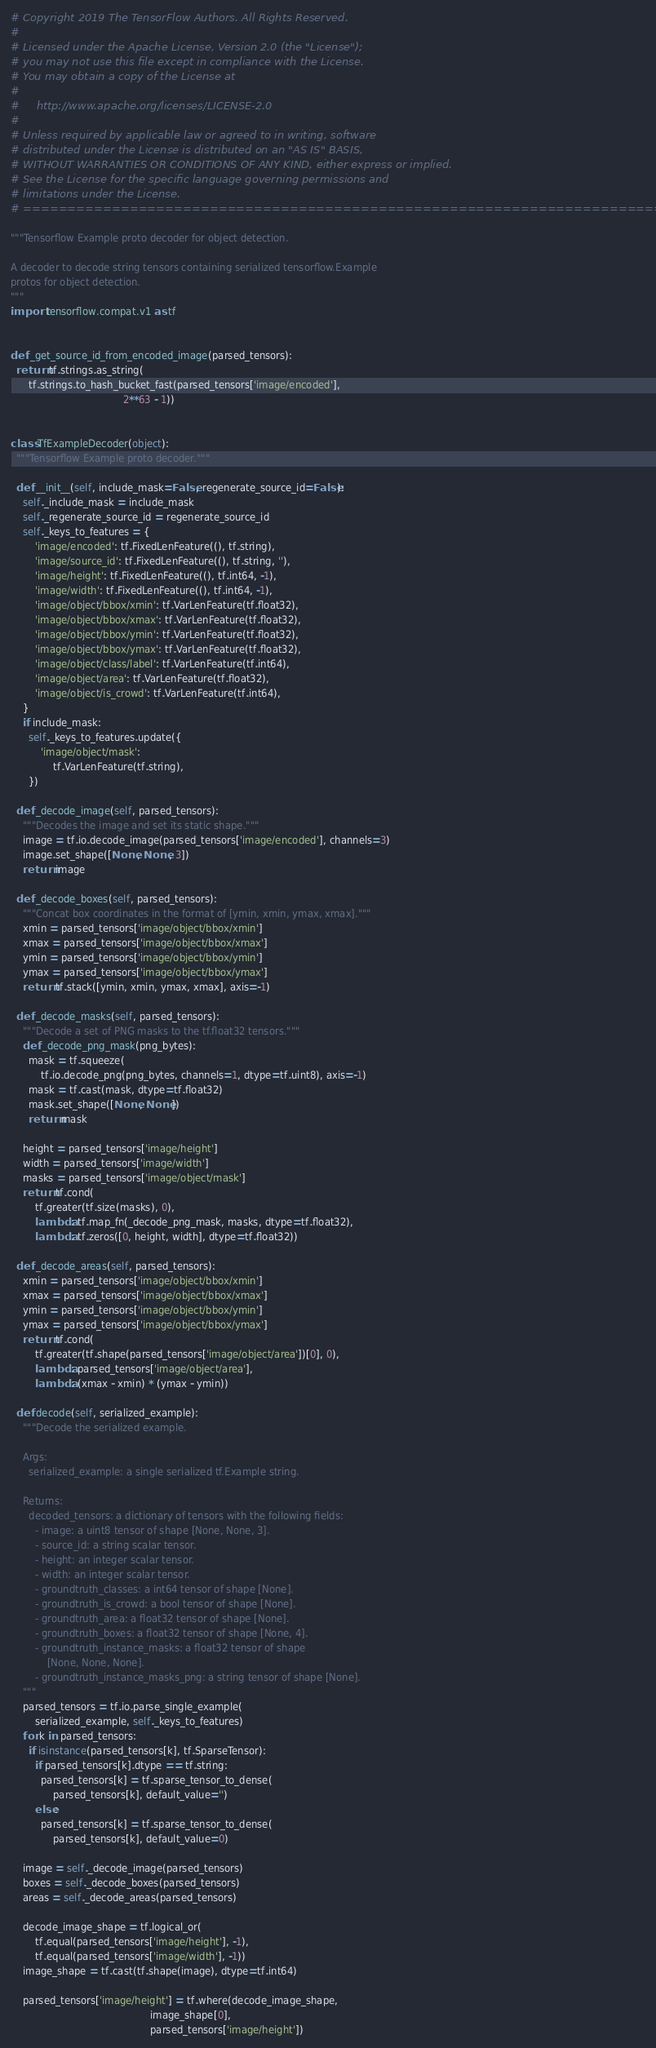<code> <loc_0><loc_0><loc_500><loc_500><_Python_># Copyright 2019 The TensorFlow Authors. All Rights Reserved.
#
# Licensed under the Apache License, Version 2.0 (the "License");
# you may not use this file except in compliance with the License.
# You may obtain a copy of the License at
#
#     http://www.apache.org/licenses/LICENSE-2.0
#
# Unless required by applicable law or agreed to in writing, software
# distributed under the License is distributed on an "AS IS" BASIS,
# WITHOUT WARRANTIES OR CONDITIONS OF ANY KIND, either express or implied.
# See the License for the specific language governing permissions and
# limitations under the License.
# ==============================================================================

"""Tensorflow Example proto decoder for object detection.

A decoder to decode string tensors containing serialized tensorflow.Example
protos for object detection.
"""
import tensorflow.compat.v1 as tf


def _get_source_id_from_encoded_image(parsed_tensors):
  return tf.strings.as_string(
      tf.strings.to_hash_bucket_fast(parsed_tensors['image/encoded'],
                                     2**63 - 1))


class TfExampleDecoder(object):
  """Tensorflow Example proto decoder."""

  def __init__(self, include_mask=False, regenerate_source_id=False):
    self._include_mask = include_mask
    self._regenerate_source_id = regenerate_source_id
    self._keys_to_features = {
        'image/encoded': tf.FixedLenFeature((), tf.string),
        'image/source_id': tf.FixedLenFeature((), tf.string, ''),
        'image/height': tf.FixedLenFeature((), tf.int64, -1),
        'image/width': tf.FixedLenFeature((), tf.int64, -1),
        'image/object/bbox/xmin': tf.VarLenFeature(tf.float32),
        'image/object/bbox/xmax': tf.VarLenFeature(tf.float32),
        'image/object/bbox/ymin': tf.VarLenFeature(tf.float32),
        'image/object/bbox/ymax': tf.VarLenFeature(tf.float32),
        'image/object/class/label': tf.VarLenFeature(tf.int64),
        'image/object/area': tf.VarLenFeature(tf.float32),
        'image/object/is_crowd': tf.VarLenFeature(tf.int64),
    }
    if include_mask:
      self._keys_to_features.update({
          'image/object/mask':
              tf.VarLenFeature(tf.string),
      })

  def _decode_image(self, parsed_tensors):
    """Decodes the image and set its static shape."""
    image = tf.io.decode_image(parsed_tensors['image/encoded'], channels=3)
    image.set_shape([None, None, 3])
    return image

  def _decode_boxes(self, parsed_tensors):
    """Concat box coordinates in the format of [ymin, xmin, ymax, xmax]."""
    xmin = parsed_tensors['image/object/bbox/xmin']
    xmax = parsed_tensors['image/object/bbox/xmax']
    ymin = parsed_tensors['image/object/bbox/ymin']
    ymax = parsed_tensors['image/object/bbox/ymax']
    return tf.stack([ymin, xmin, ymax, xmax], axis=-1)

  def _decode_masks(self, parsed_tensors):
    """Decode a set of PNG masks to the tf.float32 tensors."""
    def _decode_png_mask(png_bytes):
      mask = tf.squeeze(
          tf.io.decode_png(png_bytes, channels=1, dtype=tf.uint8), axis=-1)
      mask = tf.cast(mask, dtype=tf.float32)
      mask.set_shape([None, None])
      return mask

    height = parsed_tensors['image/height']
    width = parsed_tensors['image/width']
    masks = parsed_tensors['image/object/mask']
    return tf.cond(
        tf.greater(tf.size(masks), 0),
        lambda: tf.map_fn(_decode_png_mask, masks, dtype=tf.float32),
        lambda: tf.zeros([0, height, width], dtype=tf.float32))

  def _decode_areas(self, parsed_tensors):
    xmin = parsed_tensors['image/object/bbox/xmin']
    xmax = parsed_tensors['image/object/bbox/xmax']
    ymin = parsed_tensors['image/object/bbox/ymin']
    ymax = parsed_tensors['image/object/bbox/ymax']
    return tf.cond(
        tf.greater(tf.shape(parsed_tensors['image/object/area'])[0], 0),
        lambda: parsed_tensors['image/object/area'],
        lambda: (xmax - xmin) * (ymax - ymin))

  def decode(self, serialized_example):
    """Decode the serialized example.

    Args:
      serialized_example: a single serialized tf.Example string.

    Returns:
      decoded_tensors: a dictionary of tensors with the following fields:
        - image: a uint8 tensor of shape [None, None, 3].
        - source_id: a string scalar tensor.
        - height: an integer scalar tensor.
        - width: an integer scalar tensor.
        - groundtruth_classes: a int64 tensor of shape [None].
        - groundtruth_is_crowd: a bool tensor of shape [None].
        - groundtruth_area: a float32 tensor of shape [None].
        - groundtruth_boxes: a float32 tensor of shape [None, 4].
        - groundtruth_instance_masks: a float32 tensor of shape
            [None, None, None].
        - groundtruth_instance_masks_png: a string tensor of shape [None].
    """
    parsed_tensors = tf.io.parse_single_example(
        serialized_example, self._keys_to_features)
    for k in parsed_tensors:
      if isinstance(parsed_tensors[k], tf.SparseTensor):
        if parsed_tensors[k].dtype == tf.string:
          parsed_tensors[k] = tf.sparse_tensor_to_dense(
              parsed_tensors[k], default_value='')
        else:
          parsed_tensors[k] = tf.sparse_tensor_to_dense(
              parsed_tensors[k], default_value=0)

    image = self._decode_image(parsed_tensors)
    boxes = self._decode_boxes(parsed_tensors)
    areas = self._decode_areas(parsed_tensors)

    decode_image_shape = tf.logical_or(
        tf.equal(parsed_tensors['image/height'], -1),
        tf.equal(parsed_tensors['image/width'], -1))
    image_shape = tf.cast(tf.shape(image), dtype=tf.int64)

    parsed_tensors['image/height'] = tf.where(decode_image_shape,
                                              image_shape[0],
                                              parsed_tensors['image/height'])</code> 